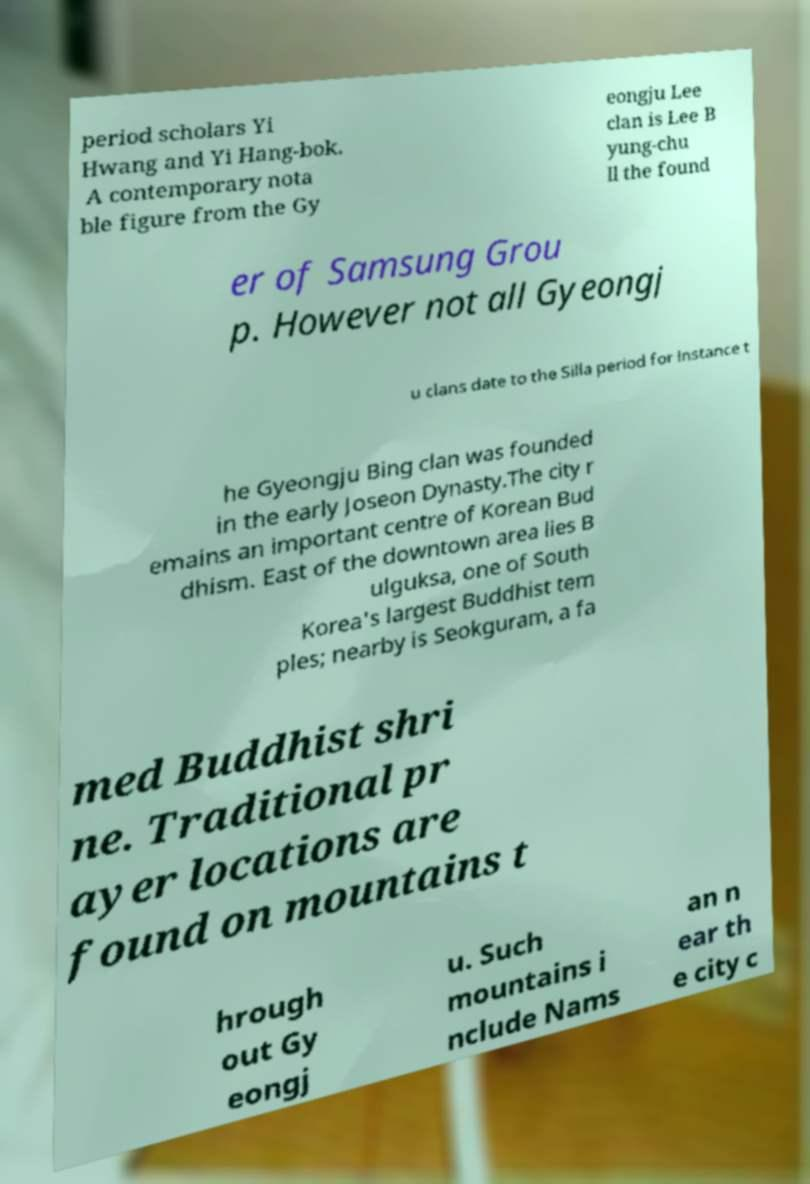Could you assist in decoding the text presented in this image and type it out clearly? period scholars Yi Hwang and Yi Hang-bok. A contemporary nota ble figure from the Gy eongju Lee clan is Lee B yung-chu ll the found er of Samsung Grou p. However not all Gyeongj u clans date to the Silla period for instance t he Gyeongju Bing clan was founded in the early Joseon Dynasty.The city r emains an important centre of Korean Bud dhism. East of the downtown area lies B ulguksa, one of South Korea's largest Buddhist tem ples; nearby is Seokguram, a fa med Buddhist shri ne. Traditional pr ayer locations are found on mountains t hrough out Gy eongj u. Such mountains i nclude Nams an n ear th e city c 